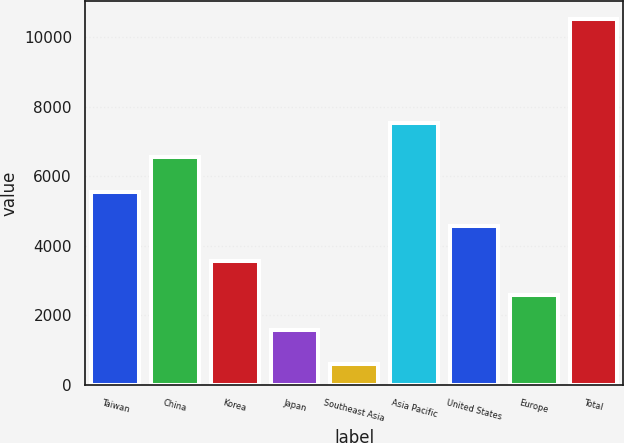<chart> <loc_0><loc_0><loc_500><loc_500><bar_chart><fcel>Taiwan<fcel>China<fcel>Korea<fcel>Japan<fcel>Southeast Asia<fcel>Asia Pacific<fcel>United States<fcel>Europe<fcel>Total<nl><fcel>5554.5<fcel>6547<fcel>3569.5<fcel>1584.5<fcel>592<fcel>7539.5<fcel>4562<fcel>2577<fcel>10517<nl></chart> 